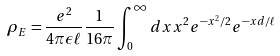<formula> <loc_0><loc_0><loc_500><loc_500>\rho _ { E } = \frac { e ^ { 2 } } { 4 \pi \epsilon \ell } \frac { 1 } { 1 6 \pi } \int _ { 0 } ^ { \infty } d x x ^ { 2 } e ^ { - x ^ { 2 } / 2 } e ^ { - x d / \ell }</formula> 